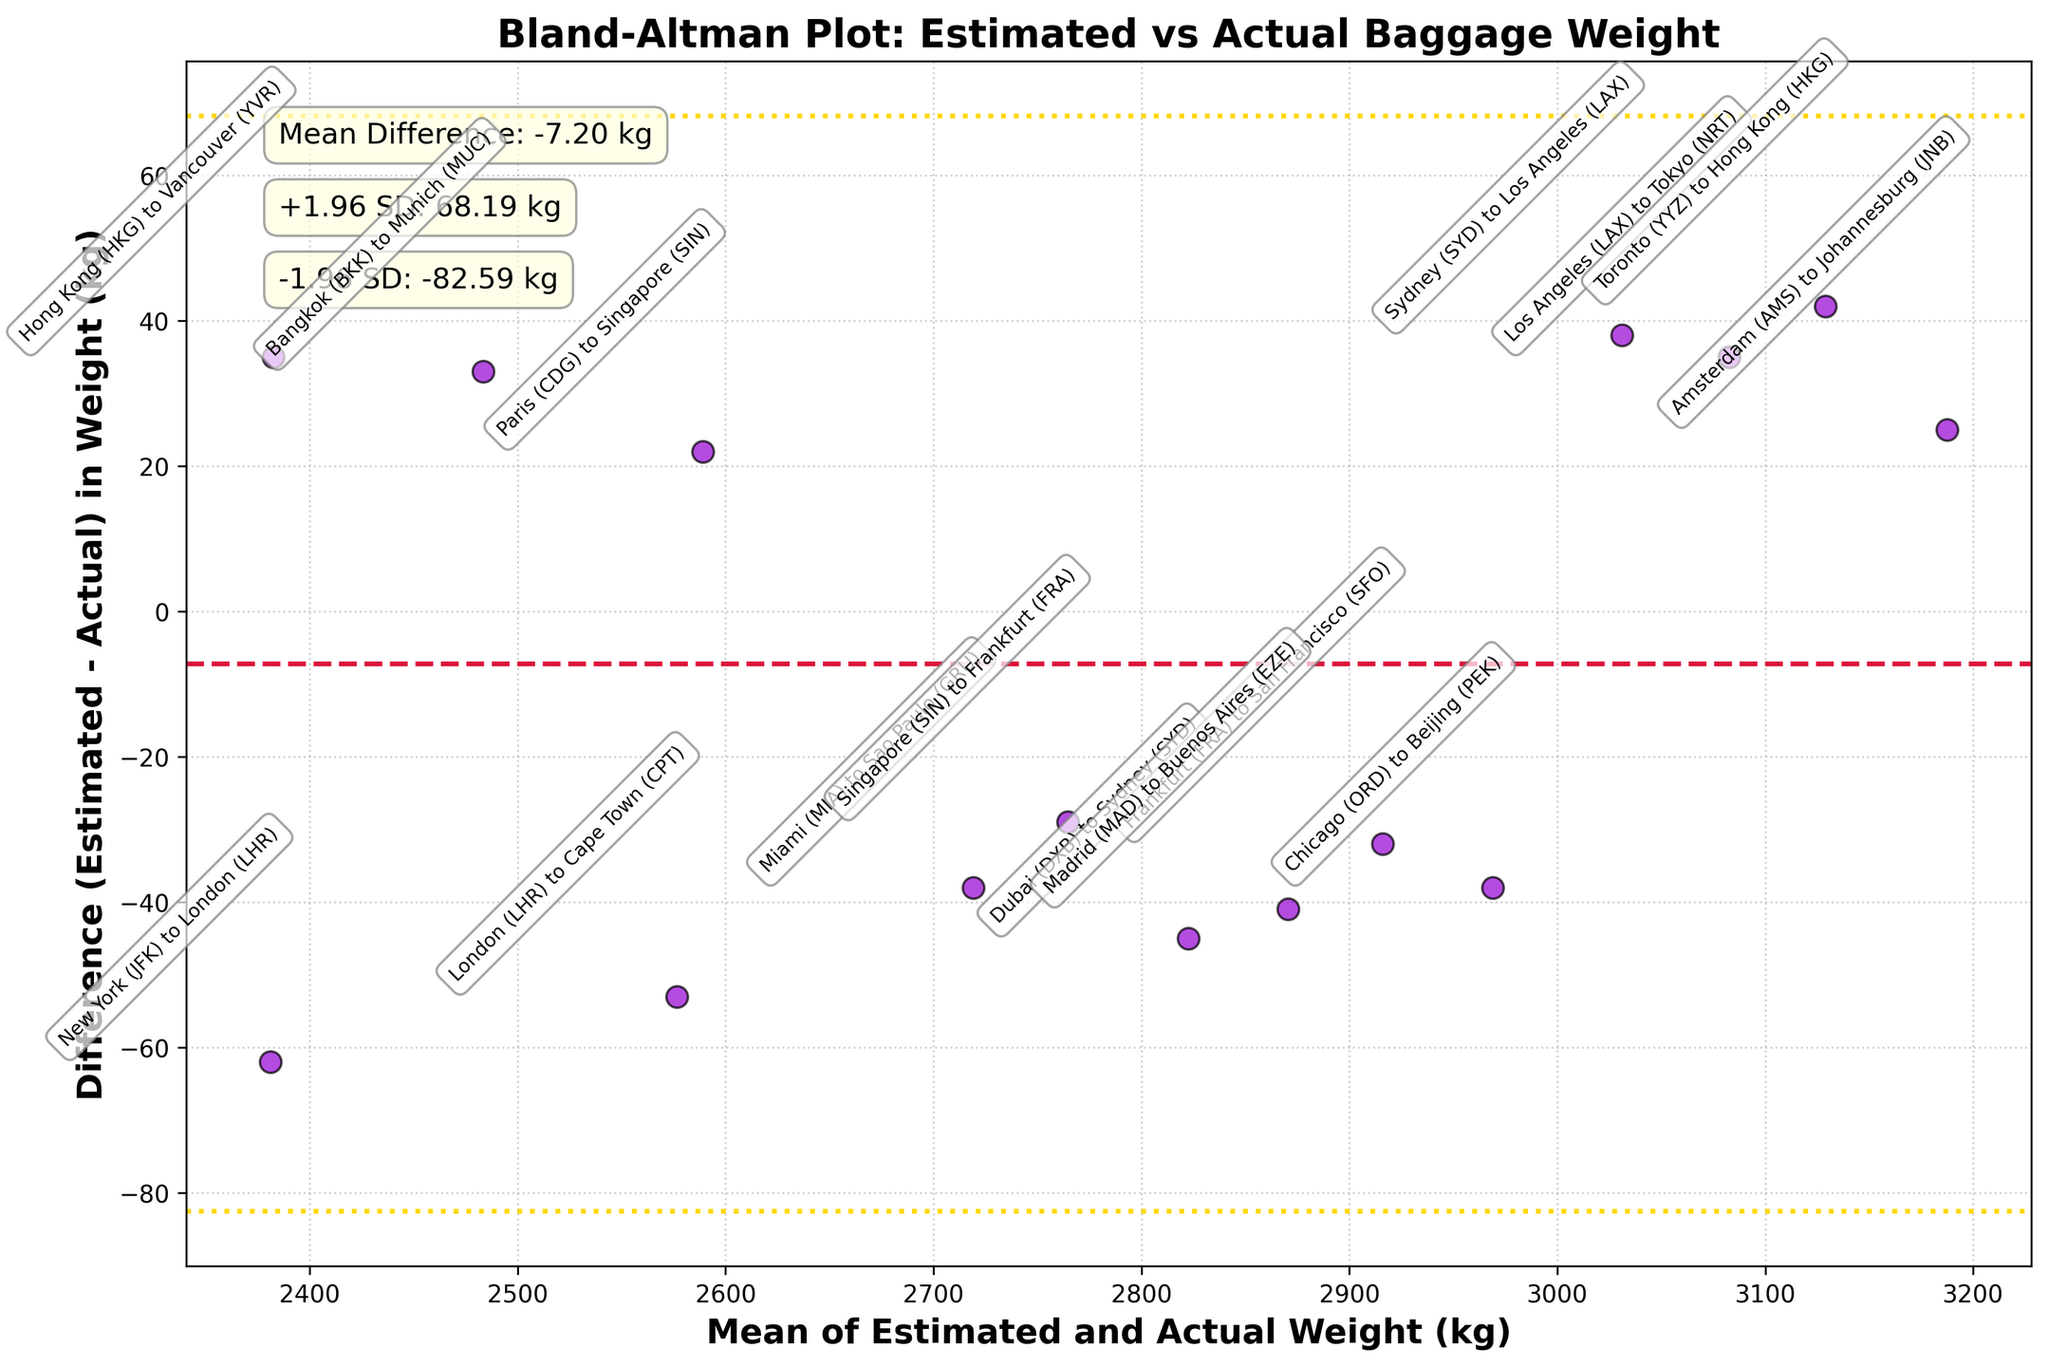What is the title of the figure? The title is usually at the top of the figure and represents a brief description of what the plot is about.
Answer: Bland-Altman Plot: Estimated vs Actual Baggage Weight How many data points are plotted in the figure? Count the number of data points (or dots) present in the scatter plot of the figure.
Answer: 15 What colors are used for the data points and the horizontal lines? Observing the figure, we can notice the colors used for the data points and horizontal lines. The data points are in darkviolet, and the horizontal lines for the mean difference and ±1.96 SD are crimson and gold, respectively.
Answer: Darkviolet and crimson/gold What does the x-axis represent? The x-axis label can be read to determine what it represents.
Answer: Mean of Estimated and Actual Weight (kg) What does the y-axis represent? The y-axis label can be read to determine what it represents.
Answer: Difference (Estimated - Actual) in Weight (kg) What is the mean difference between the estimated and actual baggage weight? Look for the annotative text in the plot that mentions the mean difference.
Answer: -2.67 kg What is the range for the ±1.96 SD lines? The ±1.96 SD lines are usually annotated on the plot. It mentions the specific values for these lines.
Answer: +1.96 SD: 62.87 kg and -1.96 SD: -68.21 kg Which flight route shows the highest positive difference? By locating the point with the highest positive y-value, find out the flight route annotation closest to this point.
Answer: London (LHR) to Cape Town (CPT) Which flight route shows the highest negative difference? By locating the point with the lowest (most negative) y-value, find out the flight route annotation closest to this point.
Answer: Hong Kong (HKG) to Vancouver (YVR) Which flight route has a mean weight closest to 2500 kg? Identify the data point (dot) closest to the 2500 kg mark on the x-axis and note the corresponding flight route.
Answer: Bangkok (BKK) to Munich (MUC) 